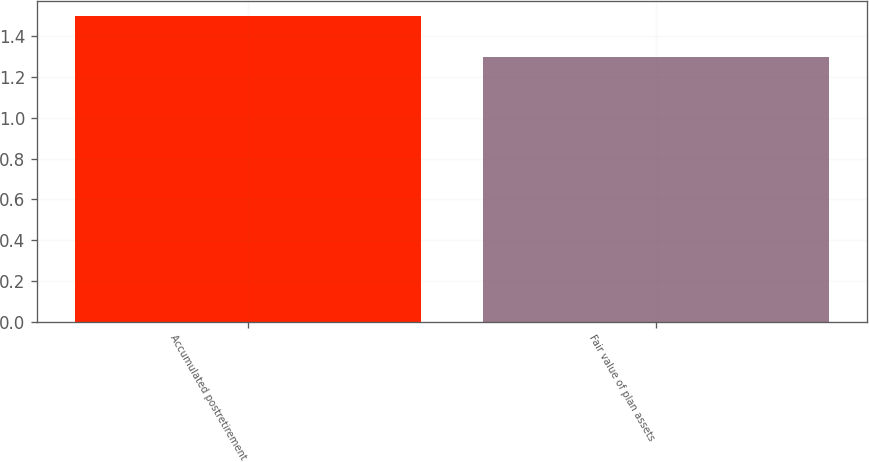Convert chart. <chart><loc_0><loc_0><loc_500><loc_500><bar_chart><fcel>Accumulated postretirement<fcel>Fair value of plan assets<nl><fcel>1.5<fcel>1.3<nl></chart> 